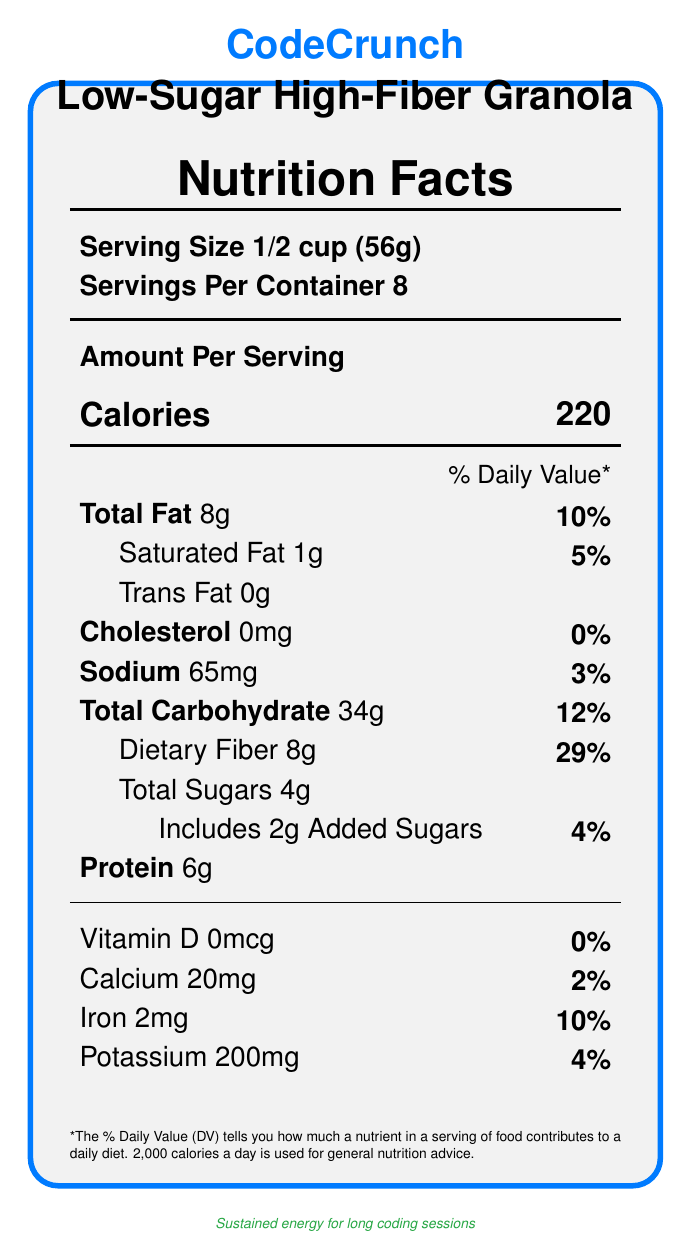What is the serving size of CodeCrunch Low-Sugar High-Fiber Granola? The document explicitly states that the serving size is 1/2 cup (56g).
Answer: 1/2 cup (56g) How many servings are there per container? The document mentions that there are 8 servings per container.
Answer: 8 How many calories are there per serving? The document states that each serving contains 220 calories.
Answer: 220 calories What is the total amount of sugars in a serving? The document indicates that the total amount of sugars in a serving is 4g.
Answer: 4g How much dietary fiber does one serving contain? According to the document, one serving contains 8g of dietary fiber.
Answer: 8g What percentage of the daily value of iron does one serving provide? The daily value of iron from one serving is listed as 10% in the document.
Answer: 10% How much sodium is in one serving? The document shows that one serving contains 65mg of sodium.
Answer: 65mg Which of the following ingredients are included in CodeCrunch Granola? A. Whole grain oats B. Almonds C. Chia seeds D. Coconut oil E. All of the above The ingredients list in the document includes whole grain oats, almonds, chia seeds, and coconut oil.
Answer: E. All of the above What is the main benefit for tech professionals provided by the high fiber content in CodeCrunch Granola? A. Increased energy B. Better focus C. Improved digestive health D. Stronger muscles The document states that high fiber content supports digestive health during sedentary work, which is beneficial for tech professionals.
Answer: C. Improved digestive health Does CodeCrunch Granola contain any artificial preservatives or flavors? Yes/No The document claims that CodeCrunch Granola has no artificial preservatives or flavors.
Answer: No Summarize the main idea of this document. This document describes the nutritional content and health benefits of CodeCrunch Low-Sugar High-Fiber Granola, emphasizing its suitability for health-conscious tech professionals. The granola offers sustained energy, digestive health support, and stable blood glucose levels, with details on its natural ingredients and nutritional values.
Answer: CodeCrunch Low-Sugar High-Fiber Granola is a health-conscious product designed to provide sustained energy, support digestive health, and maintain stable blood glucose levels. It contains natural ingredients, is low in sugar, high in fiber, and free from artificial preservatives or flavors. The nutritional information and ingredients are presented in a clear format, highlighting its benefits for tech professionals. How much total fat is in a serving and what percentage of the daily value does it represent? According to the document, each serving has 8g of total fat, which represents 10% of the daily value.
Answer: 8g, 10% What is the calcium content per serving in milligrams? The document specifies that the calcium content per serving is 20mg.
Answer: 20mg Identify the manufacturer of CodeCrunch Granola. The document lists ByteBite Foods, Inc. as the manufacturer of CodeCrunch Granola.
Answer: ByteBite Foods, Inc. Is there any Vitamin D in this granola? The document states that the amount of Vitamin D in this granola is 0mcg, which is 0% of the daily value.
Answer: No How is CodeCrunch Granola beneficial for long coding sessions? The document explains that the granola provides sustained energy for long coding sessions, making it suitable for tech professionals.
Answer: Provides sustained energy What is the protein content in a serving? The document mentions that each serving of CodeCrunch Granola contains 6g of protein.
Answer: 6g How much potassium is in a serving? According to the document, each serving contains 200mg of potassium.
Answer: 200mg Can you tell the price of the product from the document? The document does not provide any information regarding the price of CodeCrunch Granola.
Answer: Cannot be determined 